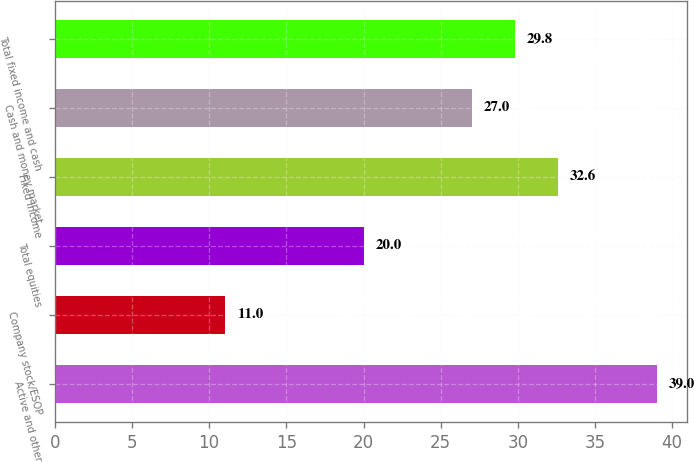Convert chart to OTSL. <chart><loc_0><loc_0><loc_500><loc_500><bar_chart><fcel>Active and other<fcel>Company stock/ESOP<fcel>Total equities<fcel>Fixed income<fcel>Cash and money market<fcel>Total fixed income and cash<nl><fcel>39<fcel>11<fcel>20<fcel>32.6<fcel>27<fcel>29.8<nl></chart> 